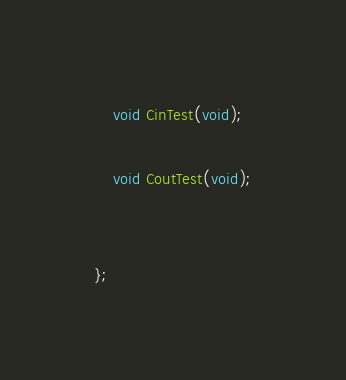Convert code to text. <code><loc_0><loc_0><loc_500><loc_500><_C_>
	void CinTest(void);

	void CoutTest(void);


};
</code> 